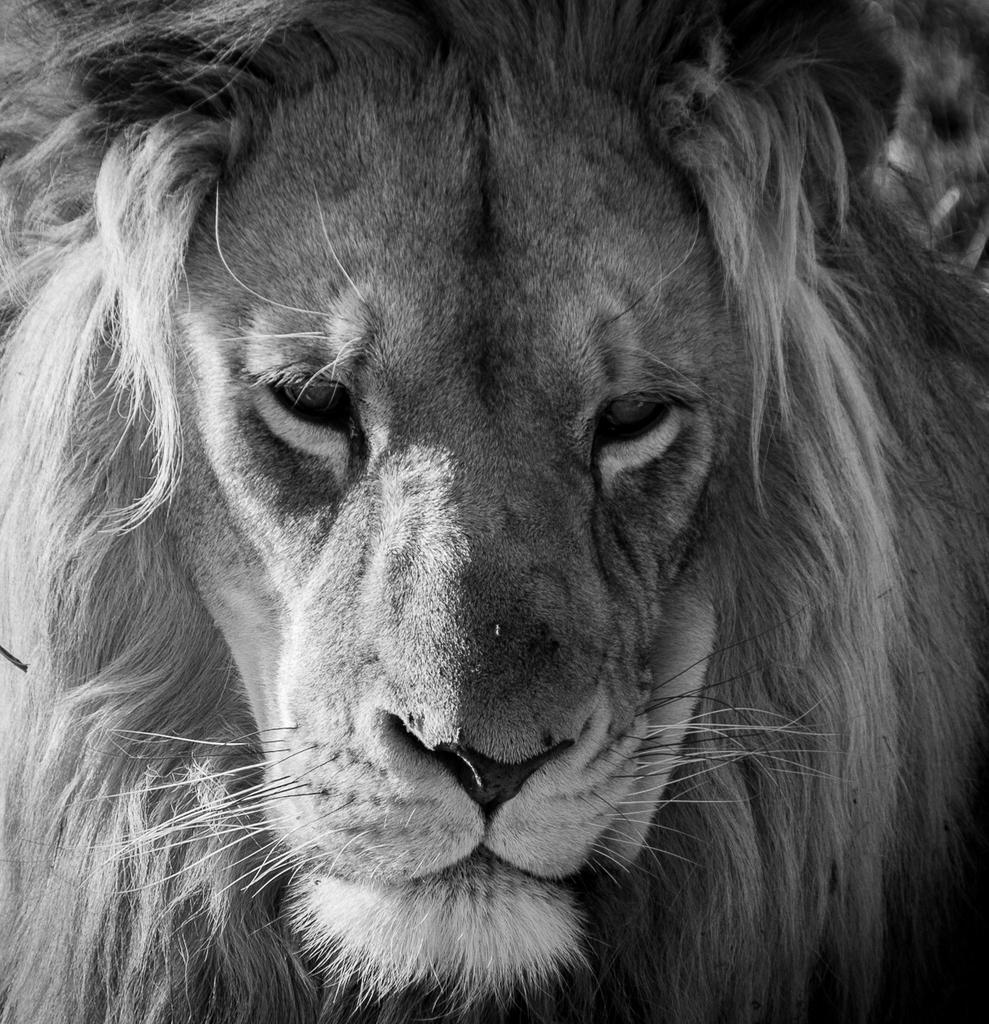Can you describe this image briefly? In this image, we can see a lion face. 